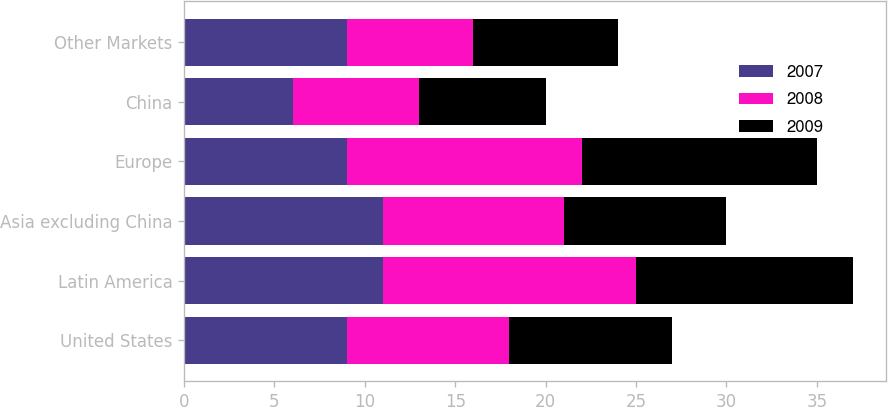<chart> <loc_0><loc_0><loc_500><loc_500><stacked_bar_chart><ecel><fcel>United States<fcel>Latin America<fcel>Asia excluding China<fcel>Europe<fcel>China<fcel>Other Markets<nl><fcel>2007<fcel>9<fcel>11<fcel>11<fcel>9<fcel>6<fcel>9<nl><fcel>2008<fcel>9<fcel>14<fcel>10<fcel>13<fcel>7<fcel>7<nl><fcel>2009<fcel>9<fcel>12<fcel>9<fcel>13<fcel>7<fcel>8<nl></chart> 